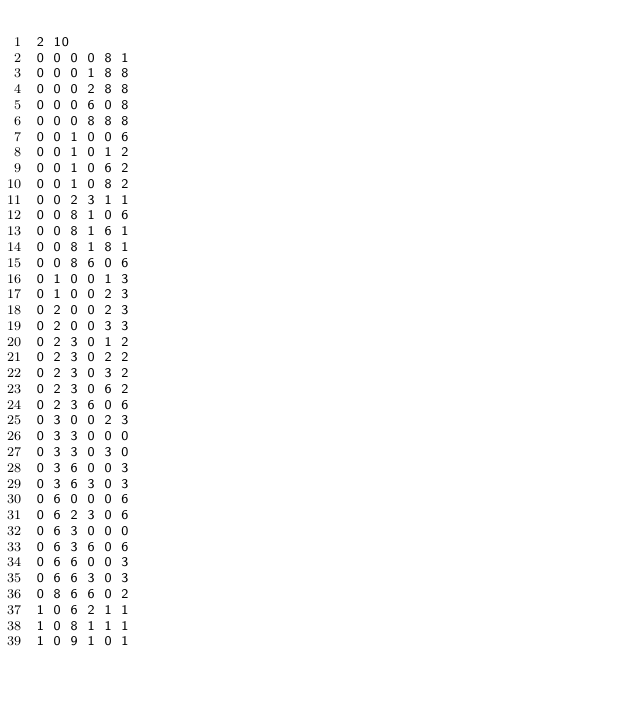<code> <loc_0><loc_0><loc_500><loc_500><_SQL_>2 10
0 0 0 0 8 1
0 0 0 1 8 8
0 0 0 2 8 8
0 0 0 6 0 8
0 0 0 8 8 8
0 0 1 0 0 6
0 0 1 0 1 2
0 0 1 0 6 2
0 0 1 0 8 2
0 0 2 3 1 1
0 0 8 1 0 6
0 0 8 1 6 1
0 0 8 1 8 1
0 0 8 6 0 6
0 1 0 0 1 3
0 1 0 0 2 3
0 2 0 0 2 3
0 2 0 0 3 3
0 2 3 0 1 2
0 2 3 0 2 2
0 2 3 0 3 2
0 2 3 0 6 2
0 2 3 6 0 6
0 3 0 0 2 3
0 3 3 0 0 0
0 3 3 0 3 0
0 3 6 0 0 3
0 3 6 3 0 3
0 6 0 0 0 6
0 6 2 3 0 6
0 6 3 0 0 0
0 6 3 6 0 6
0 6 6 0 0 3
0 6 6 3 0 3
0 8 6 6 0 2
1 0 6 2 1 1
1 0 8 1 1 1
1 0 9 1 0 1</code> 